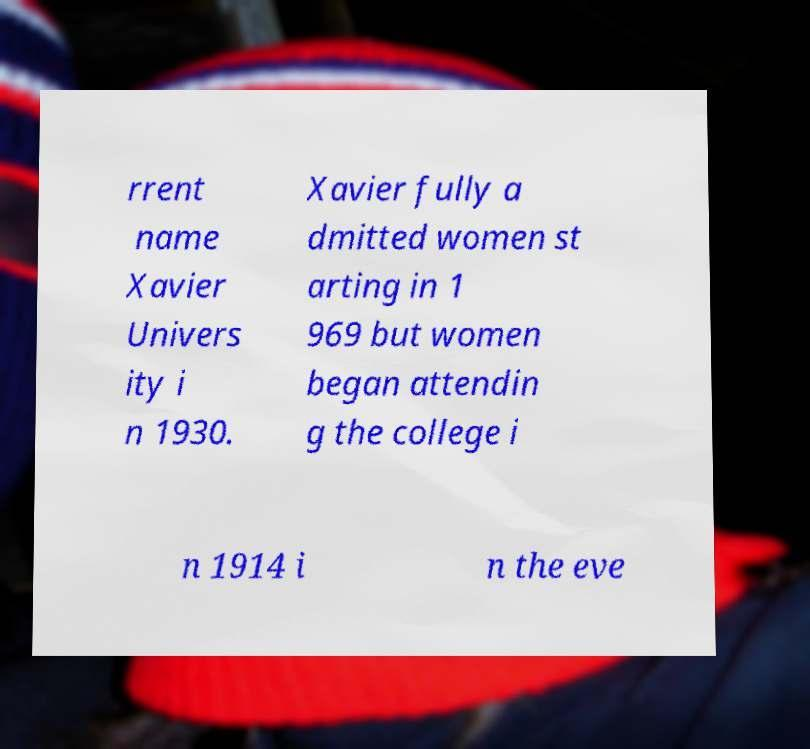There's text embedded in this image that I need extracted. Can you transcribe it verbatim? rrent name Xavier Univers ity i n 1930. Xavier fully a dmitted women st arting in 1 969 but women began attendin g the college i n 1914 i n the eve 